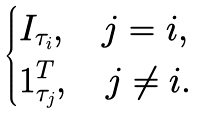<formula> <loc_0><loc_0><loc_500><loc_500>\begin{cases} I _ { \tau _ { i } } , \quad j = i , \\ { 1 } _ { \tau _ { j } } ^ { T } , \quad j \neq i . \end{cases}</formula> 